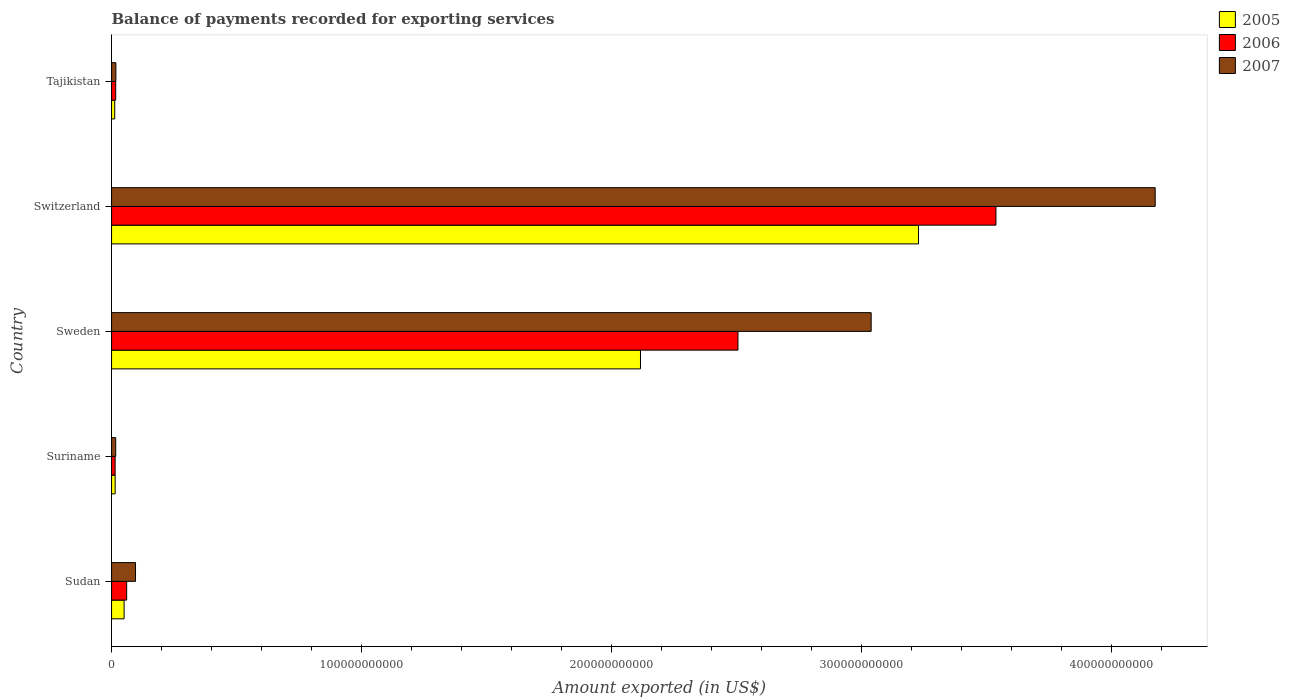Are the number of bars per tick equal to the number of legend labels?
Give a very brief answer. Yes. How many bars are there on the 5th tick from the bottom?
Keep it short and to the point. 3. What is the label of the 1st group of bars from the top?
Ensure brevity in your answer.  Tajikistan. What is the amount exported in 2005 in Suriname?
Keep it short and to the point. 1.44e+09. Across all countries, what is the maximum amount exported in 2006?
Offer a very short reply. 3.54e+11. Across all countries, what is the minimum amount exported in 2007?
Ensure brevity in your answer.  1.66e+09. In which country was the amount exported in 2007 maximum?
Ensure brevity in your answer.  Switzerland. In which country was the amount exported in 2007 minimum?
Your answer should be very brief. Suriname. What is the total amount exported in 2005 in the graph?
Provide a short and direct response. 5.42e+11. What is the difference between the amount exported in 2007 in Switzerland and that in Tajikistan?
Make the answer very short. 4.16e+11. What is the difference between the amount exported in 2007 in Sudan and the amount exported in 2006 in Sweden?
Give a very brief answer. -2.41e+11. What is the average amount exported in 2005 per country?
Offer a very short reply. 1.08e+11. What is the difference between the amount exported in 2006 and amount exported in 2005 in Switzerland?
Your answer should be very brief. 3.10e+1. What is the ratio of the amount exported in 2007 in Sweden to that in Switzerland?
Your response must be concise. 0.73. Is the amount exported in 2007 in Sweden less than that in Switzerland?
Provide a succinct answer. Yes. What is the difference between the highest and the second highest amount exported in 2005?
Offer a terse response. 1.11e+11. What is the difference between the highest and the lowest amount exported in 2007?
Keep it short and to the point. 4.16e+11. In how many countries, is the amount exported in 2006 greater than the average amount exported in 2006 taken over all countries?
Offer a very short reply. 2. Is the sum of the amount exported in 2006 in Sudan and Switzerland greater than the maximum amount exported in 2005 across all countries?
Keep it short and to the point. Yes. What does the 1st bar from the top in Tajikistan represents?
Provide a short and direct response. 2007. What does the 1st bar from the bottom in Tajikistan represents?
Your answer should be compact. 2005. Is it the case that in every country, the sum of the amount exported in 2007 and amount exported in 2006 is greater than the amount exported in 2005?
Offer a very short reply. Yes. What is the difference between two consecutive major ticks on the X-axis?
Your answer should be compact. 1.00e+11. How many legend labels are there?
Give a very brief answer. 3. What is the title of the graph?
Keep it short and to the point. Balance of payments recorded for exporting services. What is the label or title of the X-axis?
Offer a terse response. Amount exported (in US$). What is the label or title of the Y-axis?
Keep it short and to the point. Country. What is the Amount exported (in US$) of 2005 in Sudan?
Offer a terse response. 5.02e+09. What is the Amount exported (in US$) in 2006 in Sudan?
Provide a succinct answer. 6.04e+09. What is the Amount exported (in US$) in 2007 in Sudan?
Offer a terse response. 9.58e+09. What is the Amount exported (in US$) of 2005 in Suriname?
Offer a very short reply. 1.44e+09. What is the Amount exported (in US$) of 2006 in Suriname?
Your answer should be compact. 1.44e+09. What is the Amount exported (in US$) in 2007 in Suriname?
Your answer should be very brief. 1.66e+09. What is the Amount exported (in US$) in 2005 in Sweden?
Provide a succinct answer. 2.12e+11. What is the Amount exported (in US$) of 2006 in Sweden?
Offer a very short reply. 2.51e+11. What is the Amount exported (in US$) of 2007 in Sweden?
Provide a short and direct response. 3.04e+11. What is the Amount exported (in US$) of 2005 in Switzerland?
Offer a terse response. 3.23e+11. What is the Amount exported (in US$) in 2006 in Switzerland?
Offer a very short reply. 3.54e+11. What is the Amount exported (in US$) of 2007 in Switzerland?
Keep it short and to the point. 4.17e+11. What is the Amount exported (in US$) of 2005 in Tajikistan?
Your response must be concise. 1.26e+09. What is the Amount exported (in US$) of 2006 in Tajikistan?
Ensure brevity in your answer.  1.66e+09. What is the Amount exported (in US$) in 2007 in Tajikistan?
Your answer should be very brief. 1.73e+09. Across all countries, what is the maximum Amount exported (in US$) of 2005?
Your answer should be very brief. 3.23e+11. Across all countries, what is the maximum Amount exported (in US$) in 2006?
Provide a short and direct response. 3.54e+11. Across all countries, what is the maximum Amount exported (in US$) in 2007?
Ensure brevity in your answer.  4.17e+11. Across all countries, what is the minimum Amount exported (in US$) of 2005?
Ensure brevity in your answer.  1.26e+09. Across all countries, what is the minimum Amount exported (in US$) in 2006?
Your response must be concise. 1.44e+09. Across all countries, what is the minimum Amount exported (in US$) in 2007?
Provide a short and direct response. 1.66e+09. What is the total Amount exported (in US$) of 2005 in the graph?
Your answer should be very brief. 5.42e+11. What is the total Amount exported (in US$) of 2006 in the graph?
Your answer should be very brief. 6.14e+11. What is the total Amount exported (in US$) of 2007 in the graph?
Offer a very short reply. 7.34e+11. What is the difference between the Amount exported (in US$) of 2005 in Sudan and that in Suriname?
Provide a succinct answer. 3.58e+09. What is the difference between the Amount exported (in US$) in 2006 in Sudan and that in Suriname?
Offer a very short reply. 4.61e+09. What is the difference between the Amount exported (in US$) of 2007 in Sudan and that in Suriname?
Your response must be concise. 7.93e+09. What is the difference between the Amount exported (in US$) of 2005 in Sudan and that in Sweden?
Your answer should be very brief. -2.07e+11. What is the difference between the Amount exported (in US$) of 2006 in Sudan and that in Sweden?
Keep it short and to the point. -2.45e+11. What is the difference between the Amount exported (in US$) of 2007 in Sudan and that in Sweden?
Provide a succinct answer. -2.94e+11. What is the difference between the Amount exported (in US$) in 2005 in Sudan and that in Switzerland?
Your answer should be very brief. -3.18e+11. What is the difference between the Amount exported (in US$) in 2006 in Sudan and that in Switzerland?
Offer a terse response. -3.48e+11. What is the difference between the Amount exported (in US$) in 2007 in Sudan and that in Switzerland?
Offer a terse response. -4.08e+11. What is the difference between the Amount exported (in US$) of 2005 in Sudan and that in Tajikistan?
Provide a short and direct response. 3.76e+09. What is the difference between the Amount exported (in US$) in 2006 in Sudan and that in Tajikistan?
Provide a succinct answer. 4.39e+09. What is the difference between the Amount exported (in US$) in 2007 in Sudan and that in Tajikistan?
Offer a terse response. 7.85e+09. What is the difference between the Amount exported (in US$) in 2005 in Suriname and that in Sweden?
Keep it short and to the point. -2.10e+11. What is the difference between the Amount exported (in US$) in 2006 in Suriname and that in Sweden?
Your response must be concise. -2.49e+11. What is the difference between the Amount exported (in US$) in 2007 in Suriname and that in Sweden?
Keep it short and to the point. -3.02e+11. What is the difference between the Amount exported (in US$) of 2005 in Suriname and that in Switzerland?
Ensure brevity in your answer.  -3.21e+11. What is the difference between the Amount exported (in US$) of 2006 in Suriname and that in Switzerland?
Your answer should be very brief. -3.52e+11. What is the difference between the Amount exported (in US$) in 2007 in Suriname and that in Switzerland?
Make the answer very short. -4.16e+11. What is the difference between the Amount exported (in US$) in 2005 in Suriname and that in Tajikistan?
Offer a very short reply. 1.76e+08. What is the difference between the Amount exported (in US$) in 2006 in Suriname and that in Tajikistan?
Offer a very short reply. -2.22e+08. What is the difference between the Amount exported (in US$) of 2007 in Suriname and that in Tajikistan?
Keep it short and to the point. -7.20e+07. What is the difference between the Amount exported (in US$) in 2005 in Sweden and that in Switzerland?
Offer a terse response. -1.11e+11. What is the difference between the Amount exported (in US$) in 2006 in Sweden and that in Switzerland?
Offer a terse response. -1.03e+11. What is the difference between the Amount exported (in US$) in 2007 in Sweden and that in Switzerland?
Your response must be concise. -1.14e+11. What is the difference between the Amount exported (in US$) in 2005 in Sweden and that in Tajikistan?
Keep it short and to the point. 2.10e+11. What is the difference between the Amount exported (in US$) of 2006 in Sweden and that in Tajikistan?
Your answer should be very brief. 2.49e+11. What is the difference between the Amount exported (in US$) in 2007 in Sweden and that in Tajikistan?
Keep it short and to the point. 3.02e+11. What is the difference between the Amount exported (in US$) of 2005 in Switzerland and that in Tajikistan?
Your answer should be very brief. 3.22e+11. What is the difference between the Amount exported (in US$) in 2006 in Switzerland and that in Tajikistan?
Ensure brevity in your answer.  3.52e+11. What is the difference between the Amount exported (in US$) of 2007 in Switzerland and that in Tajikistan?
Your response must be concise. 4.16e+11. What is the difference between the Amount exported (in US$) of 2005 in Sudan and the Amount exported (in US$) of 2006 in Suriname?
Your response must be concise. 3.58e+09. What is the difference between the Amount exported (in US$) in 2005 in Sudan and the Amount exported (in US$) in 2007 in Suriname?
Your response must be concise. 3.36e+09. What is the difference between the Amount exported (in US$) in 2006 in Sudan and the Amount exported (in US$) in 2007 in Suriname?
Ensure brevity in your answer.  4.39e+09. What is the difference between the Amount exported (in US$) in 2005 in Sudan and the Amount exported (in US$) in 2006 in Sweden?
Make the answer very short. -2.46e+11. What is the difference between the Amount exported (in US$) in 2005 in Sudan and the Amount exported (in US$) in 2007 in Sweden?
Ensure brevity in your answer.  -2.99e+11. What is the difference between the Amount exported (in US$) in 2006 in Sudan and the Amount exported (in US$) in 2007 in Sweden?
Offer a very short reply. -2.98e+11. What is the difference between the Amount exported (in US$) in 2005 in Sudan and the Amount exported (in US$) in 2006 in Switzerland?
Give a very brief answer. -3.49e+11. What is the difference between the Amount exported (in US$) in 2005 in Sudan and the Amount exported (in US$) in 2007 in Switzerland?
Your answer should be very brief. -4.12e+11. What is the difference between the Amount exported (in US$) in 2006 in Sudan and the Amount exported (in US$) in 2007 in Switzerland?
Make the answer very short. -4.11e+11. What is the difference between the Amount exported (in US$) in 2005 in Sudan and the Amount exported (in US$) in 2006 in Tajikistan?
Your answer should be very brief. 3.36e+09. What is the difference between the Amount exported (in US$) of 2005 in Sudan and the Amount exported (in US$) of 2007 in Tajikistan?
Give a very brief answer. 3.29e+09. What is the difference between the Amount exported (in US$) in 2006 in Sudan and the Amount exported (in US$) in 2007 in Tajikistan?
Give a very brief answer. 4.32e+09. What is the difference between the Amount exported (in US$) of 2005 in Suriname and the Amount exported (in US$) of 2006 in Sweden?
Make the answer very short. -2.49e+11. What is the difference between the Amount exported (in US$) in 2005 in Suriname and the Amount exported (in US$) in 2007 in Sweden?
Provide a succinct answer. -3.02e+11. What is the difference between the Amount exported (in US$) of 2006 in Suriname and the Amount exported (in US$) of 2007 in Sweden?
Provide a short and direct response. -3.02e+11. What is the difference between the Amount exported (in US$) of 2005 in Suriname and the Amount exported (in US$) of 2006 in Switzerland?
Provide a succinct answer. -3.52e+11. What is the difference between the Amount exported (in US$) of 2005 in Suriname and the Amount exported (in US$) of 2007 in Switzerland?
Provide a succinct answer. -4.16e+11. What is the difference between the Amount exported (in US$) in 2006 in Suriname and the Amount exported (in US$) in 2007 in Switzerland?
Provide a succinct answer. -4.16e+11. What is the difference between the Amount exported (in US$) of 2005 in Suriname and the Amount exported (in US$) of 2006 in Tajikistan?
Ensure brevity in your answer.  -2.19e+08. What is the difference between the Amount exported (in US$) in 2005 in Suriname and the Amount exported (in US$) in 2007 in Tajikistan?
Ensure brevity in your answer.  -2.88e+08. What is the difference between the Amount exported (in US$) of 2006 in Suriname and the Amount exported (in US$) of 2007 in Tajikistan?
Offer a very short reply. -2.92e+08. What is the difference between the Amount exported (in US$) in 2005 in Sweden and the Amount exported (in US$) in 2006 in Switzerland?
Your response must be concise. -1.42e+11. What is the difference between the Amount exported (in US$) in 2005 in Sweden and the Amount exported (in US$) in 2007 in Switzerland?
Provide a short and direct response. -2.06e+11. What is the difference between the Amount exported (in US$) in 2006 in Sweden and the Amount exported (in US$) in 2007 in Switzerland?
Ensure brevity in your answer.  -1.67e+11. What is the difference between the Amount exported (in US$) in 2005 in Sweden and the Amount exported (in US$) in 2006 in Tajikistan?
Ensure brevity in your answer.  2.10e+11. What is the difference between the Amount exported (in US$) in 2005 in Sweden and the Amount exported (in US$) in 2007 in Tajikistan?
Offer a very short reply. 2.10e+11. What is the difference between the Amount exported (in US$) in 2006 in Sweden and the Amount exported (in US$) in 2007 in Tajikistan?
Keep it short and to the point. 2.49e+11. What is the difference between the Amount exported (in US$) of 2005 in Switzerland and the Amount exported (in US$) of 2006 in Tajikistan?
Make the answer very short. 3.21e+11. What is the difference between the Amount exported (in US$) of 2005 in Switzerland and the Amount exported (in US$) of 2007 in Tajikistan?
Keep it short and to the point. 3.21e+11. What is the difference between the Amount exported (in US$) of 2006 in Switzerland and the Amount exported (in US$) of 2007 in Tajikistan?
Give a very brief answer. 3.52e+11. What is the average Amount exported (in US$) of 2005 per country?
Your response must be concise. 1.08e+11. What is the average Amount exported (in US$) in 2006 per country?
Offer a very short reply. 1.23e+11. What is the average Amount exported (in US$) of 2007 per country?
Ensure brevity in your answer.  1.47e+11. What is the difference between the Amount exported (in US$) in 2005 and Amount exported (in US$) in 2006 in Sudan?
Make the answer very short. -1.03e+09. What is the difference between the Amount exported (in US$) in 2005 and Amount exported (in US$) in 2007 in Sudan?
Offer a very short reply. -4.56e+09. What is the difference between the Amount exported (in US$) in 2006 and Amount exported (in US$) in 2007 in Sudan?
Your answer should be compact. -3.54e+09. What is the difference between the Amount exported (in US$) of 2005 and Amount exported (in US$) of 2006 in Suriname?
Your answer should be compact. 3.50e+06. What is the difference between the Amount exported (in US$) of 2005 and Amount exported (in US$) of 2007 in Suriname?
Keep it short and to the point. -2.16e+08. What is the difference between the Amount exported (in US$) in 2006 and Amount exported (in US$) in 2007 in Suriname?
Your answer should be very brief. -2.20e+08. What is the difference between the Amount exported (in US$) of 2005 and Amount exported (in US$) of 2006 in Sweden?
Make the answer very short. -3.90e+1. What is the difference between the Amount exported (in US$) in 2005 and Amount exported (in US$) in 2007 in Sweden?
Your answer should be very brief. -9.23e+1. What is the difference between the Amount exported (in US$) in 2006 and Amount exported (in US$) in 2007 in Sweden?
Your answer should be very brief. -5.33e+1. What is the difference between the Amount exported (in US$) in 2005 and Amount exported (in US$) in 2006 in Switzerland?
Provide a succinct answer. -3.10e+1. What is the difference between the Amount exported (in US$) in 2005 and Amount exported (in US$) in 2007 in Switzerland?
Offer a very short reply. -9.47e+1. What is the difference between the Amount exported (in US$) in 2006 and Amount exported (in US$) in 2007 in Switzerland?
Your response must be concise. -6.37e+1. What is the difference between the Amount exported (in US$) in 2005 and Amount exported (in US$) in 2006 in Tajikistan?
Make the answer very short. -3.94e+08. What is the difference between the Amount exported (in US$) of 2005 and Amount exported (in US$) of 2007 in Tajikistan?
Keep it short and to the point. -4.64e+08. What is the difference between the Amount exported (in US$) of 2006 and Amount exported (in US$) of 2007 in Tajikistan?
Keep it short and to the point. -6.96e+07. What is the ratio of the Amount exported (in US$) of 2005 in Sudan to that in Suriname?
Give a very brief answer. 3.49. What is the ratio of the Amount exported (in US$) of 2006 in Sudan to that in Suriname?
Offer a terse response. 4.21. What is the ratio of the Amount exported (in US$) of 2007 in Sudan to that in Suriname?
Provide a short and direct response. 5.79. What is the ratio of the Amount exported (in US$) of 2005 in Sudan to that in Sweden?
Keep it short and to the point. 0.02. What is the ratio of the Amount exported (in US$) of 2006 in Sudan to that in Sweden?
Provide a succinct answer. 0.02. What is the ratio of the Amount exported (in US$) of 2007 in Sudan to that in Sweden?
Provide a succinct answer. 0.03. What is the ratio of the Amount exported (in US$) in 2005 in Sudan to that in Switzerland?
Provide a succinct answer. 0.02. What is the ratio of the Amount exported (in US$) of 2006 in Sudan to that in Switzerland?
Ensure brevity in your answer.  0.02. What is the ratio of the Amount exported (in US$) of 2007 in Sudan to that in Switzerland?
Your answer should be very brief. 0.02. What is the ratio of the Amount exported (in US$) of 2005 in Sudan to that in Tajikistan?
Provide a short and direct response. 3.97. What is the ratio of the Amount exported (in US$) in 2006 in Sudan to that in Tajikistan?
Provide a short and direct response. 3.64. What is the ratio of the Amount exported (in US$) of 2007 in Sudan to that in Tajikistan?
Your answer should be very brief. 5.55. What is the ratio of the Amount exported (in US$) of 2005 in Suriname to that in Sweden?
Provide a short and direct response. 0.01. What is the ratio of the Amount exported (in US$) of 2006 in Suriname to that in Sweden?
Make the answer very short. 0.01. What is the ratio of the Amount exported (in US$) of 2007 in Suriname to that in Sweden?
Your answer should be very brief. 0.01. What is the ratio of the Amount exported (in US$) in 2005 in Suriname to that in Switzerland?
Ensure brevity in your answer.  0. What is the ratio of the Amount exported (in US$) of 2006 in Suriname to that in Switzerland?
Give a very brief answer. 0. What is the ratio of the Amount exported (in US$) of 2007 in Suriname to that in Switzerland?
Offer a very short reply. 0. What is the ratio of the Amount exported (in US$) of 2005 in Suriname to that in Tajikistan?
Provide a short and direct response. 1.14. What is the ratio of the Amount exported (in US$) of 2006 in Suriname to that in Tajikistan?
Make the answer very short. 0.87. What is the ratio of the Amount exported (in US$) of 2007 in Suriname to that in Tajikistan?
Offer a terse response. 0.96. What is the ratio of the Amount exported (in US$) in 2005 in Sweden to that in Switzerland?
Your response must be concise. 0.66. What is the ratio of the Amount exported (in US$) in 2006 in Sweden to that in Switzerland?
Ensure brevity in your answer.  0.71. What is the ratio of the Amount exported (in US$) of 2007 in Sweden to that in Switzerland?
Provide a short and direct response. 0.73. What is the ratio of the Amount exported (in US$) in 2005 in Sweden to that in Tajikistan?
Your answer should be very brief. 167.39. What is the ratio of the Amount exported (in US$) in 2006 in Sweden to that in Tajikistan?
Your answer should be compact. 151.1. What is the ratio of the Amount exported (in US$) of 2007 in Sweden to that in Tajikistan?
Make the answer very short. 175.85. What is the ratio of the Amount exported (in US$) of 2005 in Switzerland to that in Tajikistan?
Your response must be concise. 255.38. What is the ratio of the Amount exported (in US$) in 2006 in Switzerland to that in Tajikistan?
Provide a short and direct response. 213.33. What is the ratio of the Amount exported (in US$) of 2007 in Switzerland to that in Tajikistan?
Your answer should be compact. 241.6. What is the difference between the highest and the second highest Amount exported (in US$) in 2005?
Make the answer very short. 1.11e+11. What is the difference between the highest and the second highest Amount exported (in US$) of 2006?
Provide a short and direct response. 1.03e+11. What is the difference between the highest and the second highest Amount exported (in US$) in 2007?
Offer a terse response. 1.14e+11. What is the difference between the highest and the lowest Amount exported (in US$) of 2005?
Offer a very short reply. 3.22e+11. What is the difference between the highest and the lowest Amount exported (in US$) in 2006?
Offer a terse response. 3.52e+11. What is the difference between the highest and the lowest Amount exported (in US$) of 2007?
Offer a very short reply. 4.16e+11. 